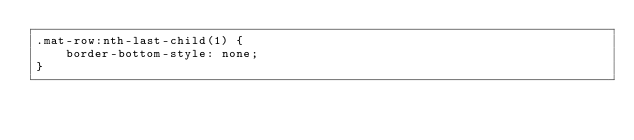<code> <loc_0><loc_0><loc_500><loc_500><_CSS_>.mat-row:nth-last-child(1) {
	border-bottom-style: none;
}
</code> 